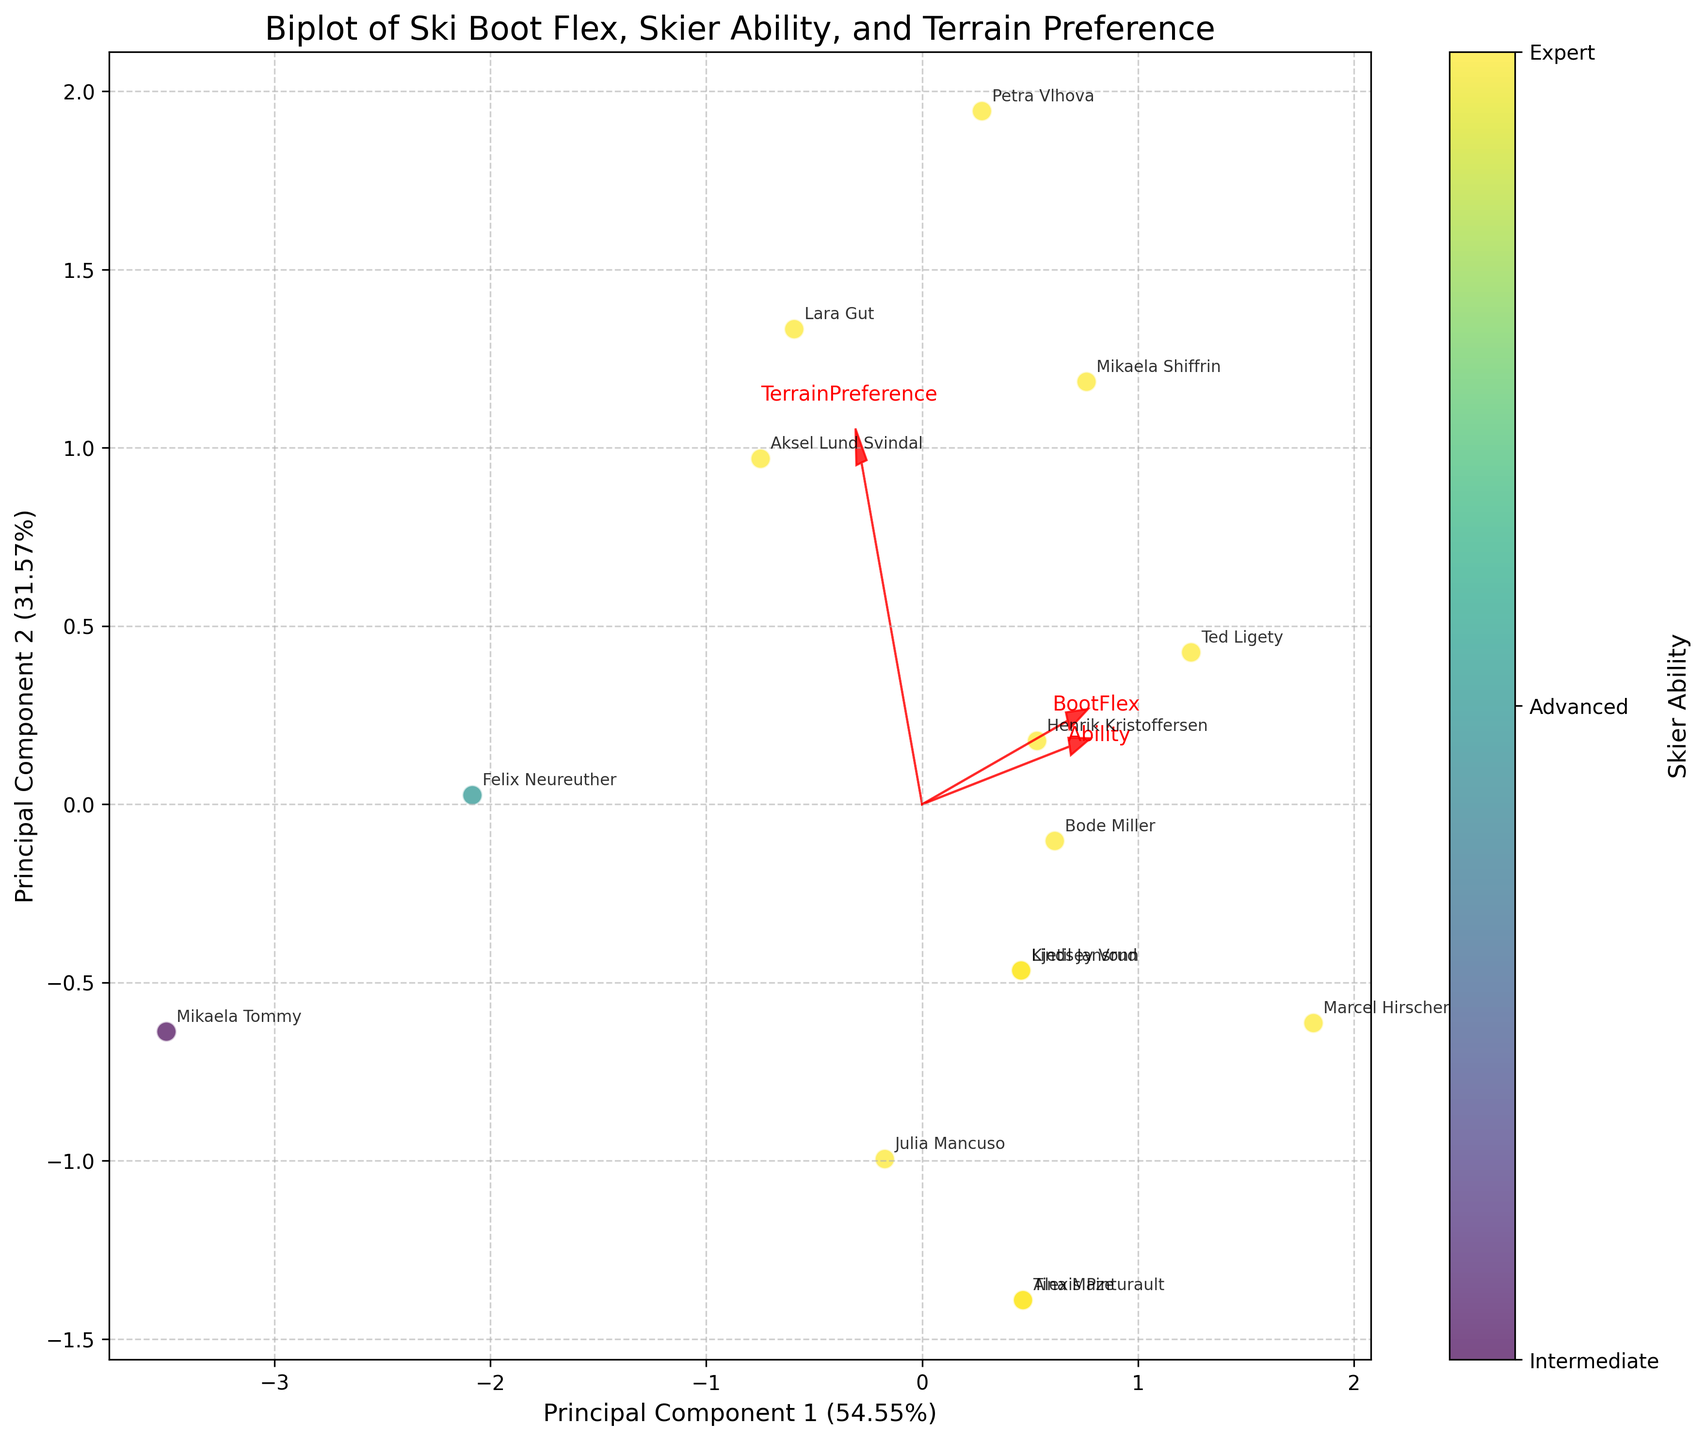How many principal components are displayed in the plot? The plot shows two principal components as indicated by the x-axis labeled "Principal Component 1" and the y-axis labeled "Principal Component 2".
Answer: 2 What is the color map used to represent the skier ability levels? The plot uses a viridis color map to represent skier ability levels, transitioning from light to dark shades. Intermediate skiers are in the lightest shade, advanced skiers are in the medium shade, and expert skiers are in the darkest shade.
Answer: viridis Which skier has the highest boot flex rating? By examining the names annotated near the data points and the arrows representing features, we see that Marcel Hirscher, with a boot flex rating of 140, is located further along the direction of the BootFlex arrow.
Answer: Marcel Hirscher Are terrain preferences correlated with boot flex ratings? By observing the direction and length of the arrows for 'BootFlex' and 'TerrainPreference,' we see they do not align closely, indicating weak or no direct correlation between them in the principal component space.
Answer: No Which skier is preferred for 'Groomed Runs' based on their name annotation and position in the plot? Mikaela Tommy is annotated near a point positioned towards the 'TerrainPreference' arrow's direction for Groomed Runs.
Answer: Mikaela Tommy How does skier ability trend with the principal components? The color bar shows skier ability, where darker shades represent higher ability. The experts (darkest shades) are generally clustered in similar regions of the plot, indicating a trend where higher abilities cluster together in the principal component space.
Answer: Higher abilities cluster together Which skier is closest to the center of the biplot, and what does that imply? Felix Neureuther's data point, annotated near the center, implies his combination of boot flex, ability, and terrain preference is closest to the average of all skiers.
Answer: Felix Neureuther What proportion of the variation is explained by the first principal component? The x-axis label indicates the first principal component explains 59.00% of the variability in the data.
Answer: 59.00% Which terrain preference is most variable in the context of principal component 2? By examining the vector representing different terrain preferences, 'Giant Slalom' aligns more with the y-axis and stretches over multiple data points, indicating higher variance in principal component 2.
Answer: Giant Slalom What can be inferred about the relationship between skier ability and boot flex? The 'Ability' and 'BootFlex' arrows pointing in similar directions suggest a positive relationship. Higher boot flex ratings generally associate with higher ability levels.
Answer: Positive relationship 